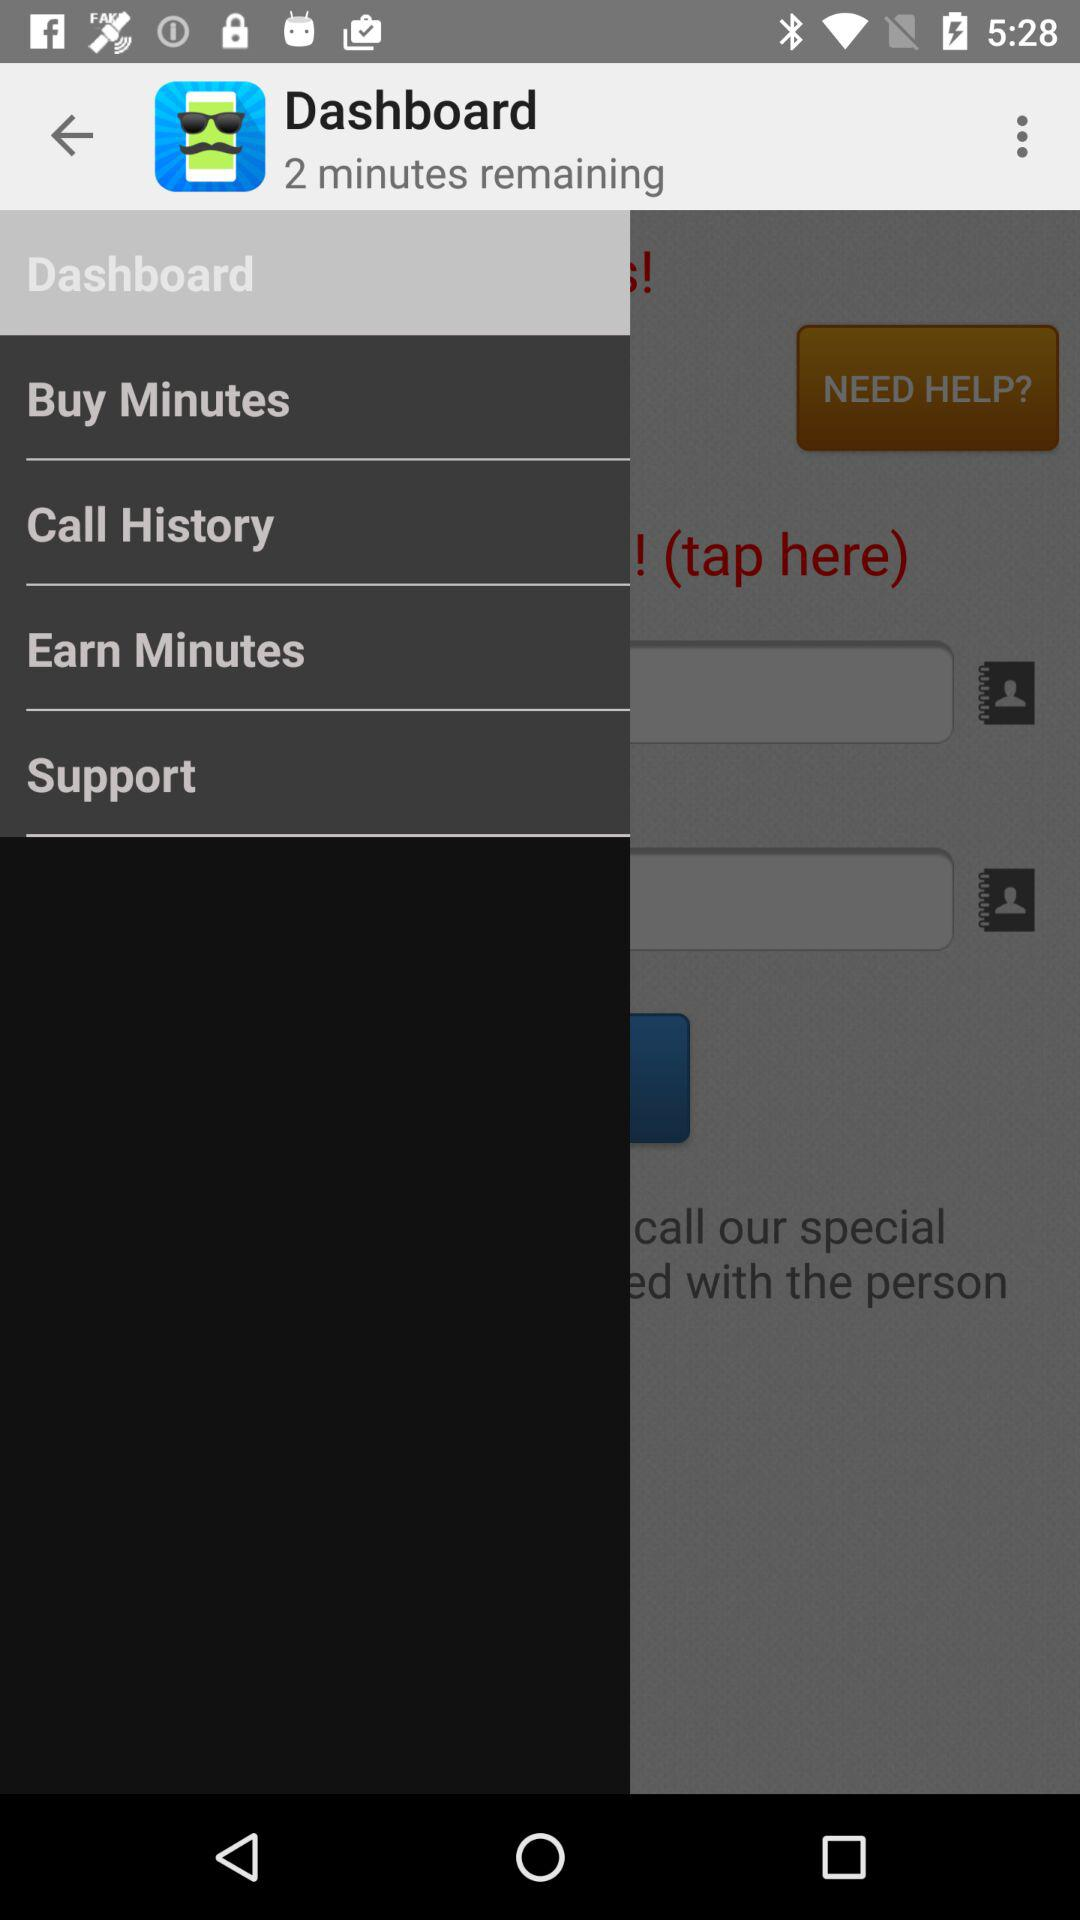Which item is selected in the menu? The selected item in the menu is "Dashboard". 